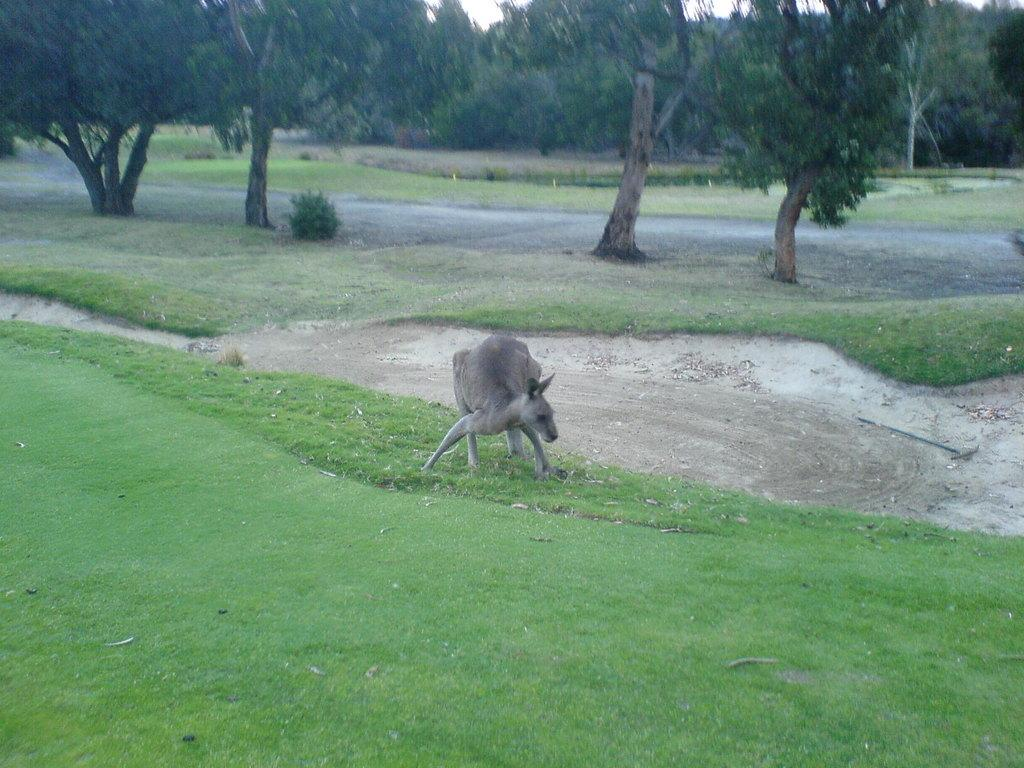What is the main subject in the center of the image? There is an animal in the center of the image. What is the animal's position in relation to the ground? The animal is on the ground. What can be seen in the background of the image? There are trees, grass, and the sky visible in the background of the image. What type of kitty detail can be seen on the door in the image? There is no kitty detail or door present in the image. 